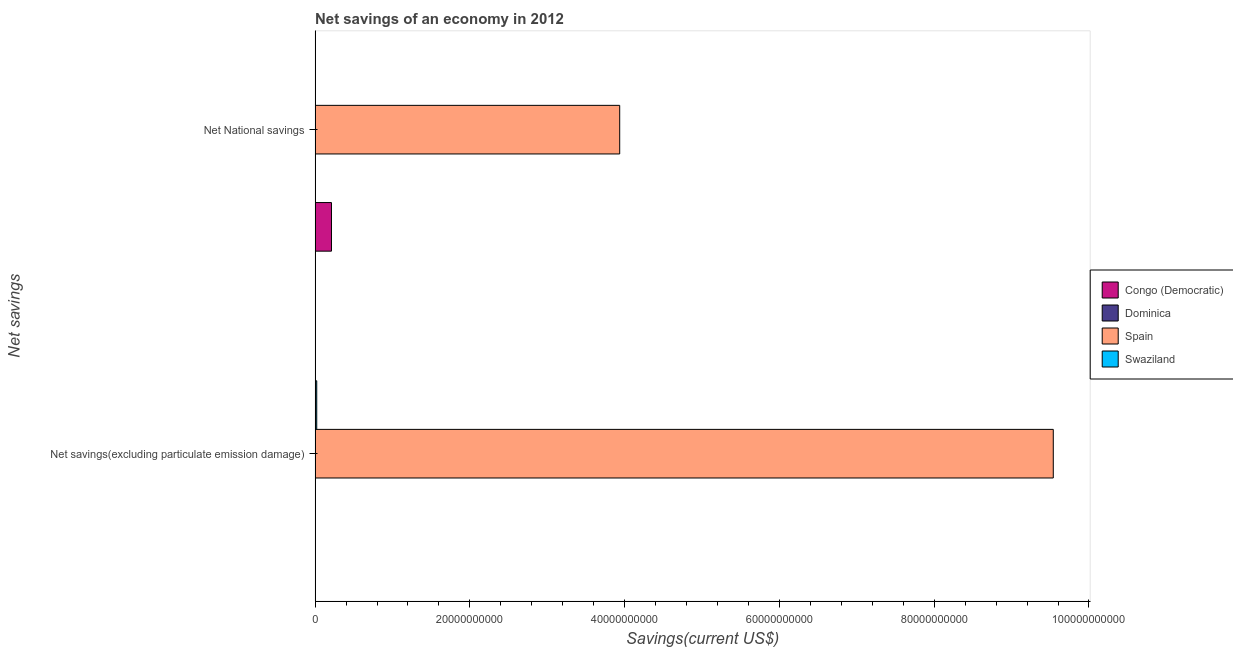How many different coloured bars are there?
Give a very brief answer. 3. How many groups of bars are there?
Offer a terse response. 2. Are the number of bars per tick equal to the number of legend labels?
Offer a very short reply. No. Are the number of bars on each tick of the Y-axis equal?
Your answer should be compact. Yes. How many bars are there on the 2nd tick from the top?
Offer a very short reply. 2. How many bars are there on the 2nd tick from the bottom?
Ensure brevity in your answer.  2. What is the label of the 1st group of bars from the top?
Ensure brevity in your answer.  Net National savings. What is the net savings(excluding particulate emission damage) in Congo (Democratic)?
Provide a succinct answer. 0. Across all countries, what is the maximum net savings(excluding particulate emission damage)?
Provide a succinct answer. 9.54e+1. Across all countries, what is the minimum net savings(excluding particulate emission damage)?
Give a very brief answer. 0. In which country was the net savings(excluding particulate emission damage) maximum?
Your answer should be compact. Spain. What is the total net national savings in the graph?
Your answer should be very brief. 4.15e+1. What is the difference between the net savings(excluding particulate emission damage) in Spain and that in Swaziland?
Offer a very short reply. 9.52e+1. What is the difference between the net national savings in Swaziland and the net savings(excluding particulate emission damage) in Spain?
Offer a terse response. -9.54e+1. What is the average net savings(excluding particulate emission damage) per country?
Your answer should be very brief. 2.39e+1. What is the difference between the net national savings and net savings(excluding particulate emission damage) in Spain?
Your answer should be compact. -5.60e+1. In how many countries, is the net national savings greater than 20000000000 US$?
Offer a terse response. 1. What is the ratio of the net national savings in Spain to that in Congo (Democratic)?
Your response must be concise. 18.61. Is the net national savings in Spain less than that in Congo (Democratic)?
Offer a very short reply. No. Are all the bars in the graph horizontal?
Your response must be concise. Yes. How many countries are there in the graph?
Provide a succinct answer. 4. What is the difference between two consecutive major ticks on the X-axis?
Give a very brief answer. 2.00e+1. Are the values on the major ticks of X-axis written in scientific E-notation?
Your answer should be very brief. No. Does the graph contain grids?
Give a very brief answer. No. How many legend labels are there?
Offer a very short reply. 4. What is the title of the graph?
Your answer should be very brief. Net savings of an economy in 2012. Does "Morocco" appear as one of the legend labels in the graph?
Offer a very short reply. No. What is the label or title of the X-axis?
Your answer should be compact. Savings(current US$). What is the label or title of the Y-axis?
Make the answer very short. Net savings. What is the Savings(current US$) in Congo (Democratic) in Net savings(excluding particulate emission damage)?
Provide a short and direct response. 0. What is the Savings(current US$) of Spain in Net savings(excluding particulate emission damage)?
Make the answer very short. 9.54e+1. What is the Savings(current US$) of Swaziland in Net savings(excluding particulate emission damage)?
Offer a very short reply. 2.11e+08. What is the Savings(current US$) in Congo (Democratic) in Net National savings?
Provide a succinct answer. 2.12e+09. What is the Savings(current US$) in Spain in Net National savings?
Offer a terse response. 3.94e+1. Across all Net savings, what is the maximum Savings(current US$) of Congo (Democratic)?
Your answer should be compact. 2.12e+09. Across all Net savings, what is the maximum Savings(current US$) of Spain?
Ensure brevity in your answer.  9.54e+1. Across all Net savings, what is the maximum Savings(current US$) of Swaziland?
Give a very brief answer. 2.11e+08. Across all Net savings, what is the minimum Savings(current US$) in Congo (Democratic)?
Give a very brief answer. 0. Across all Net savings, what is the minimum Savings(current US$) of Spain?
Make the answer very short. 3.94e+1. Across all Net savings, what is the minimum Savings(current US$) in Swaziland?
Keep it short and to the point. 0. What is the total Savings(current US$) of Congo (Democratic) in the graph?
Provide a succinct answer. 2.12e+09. What is the total Savings(current US$) in Dominica in the graph?
Offer a terse response. 0. What is the total Savings(current US$) in Spain in the graph?
Provide a short and direct response. 1.35e+11. What is the total Savings(current US$) of Swaziland in the graph?
Offer a terse response. 2.11e+08. What is the difference between the Savings(current US$) of Spain in Net savings(excluding particulate emission damage) and that in Net National savings?
Your answer should be compact. 5.60e+1. What is the average Savings(current US$) in Congo (Democratic) per Net savings?
Offer a very short reply. 1.06e+09. What is the average Savings(current US$) of Spain per Net savings?
Offer a very short reply. 6.74e+1. What is the average Savings(current US$) in Swaziland per Net savings?
Provide a short and direct response. 1.06e+08. What is the difference between the Savings(current US$) in Spain and Savings(current US$) in Swaziland in Net savings(excluding particulate emission damage)?
Provide a succinct answer. 9.52e+1. What is the difference between the Savings(current US$) of Congo (Democratic) and Savings(current US$) of Spain in Net National savings?
Your answer should be compact. -3.72e+1. What is the ratio of the Savings(current US$) in Spain in Net savings(excluding particulate emission damage) to that in Net National savings?
Keep it short and to the point. 2.42. What is the difference between the highest and the second highest Savings(current US$) in Spain?
Ensure brevity in your answer.  5.60e+1. What is the difference between the highest and the lowest Savings(current US$) in Congo (Democratic)?
Ensure brevity in your answer.  2.12e+09. What is the difference between the highest and the lowest Savings(current US$) of Spain?
Give a very brief answer. 5.60e+1. What is the difference between the highest and the lowest Savings(current US$) of Swaziland?
Ensure brevity in your answer.  2.11e+08. 